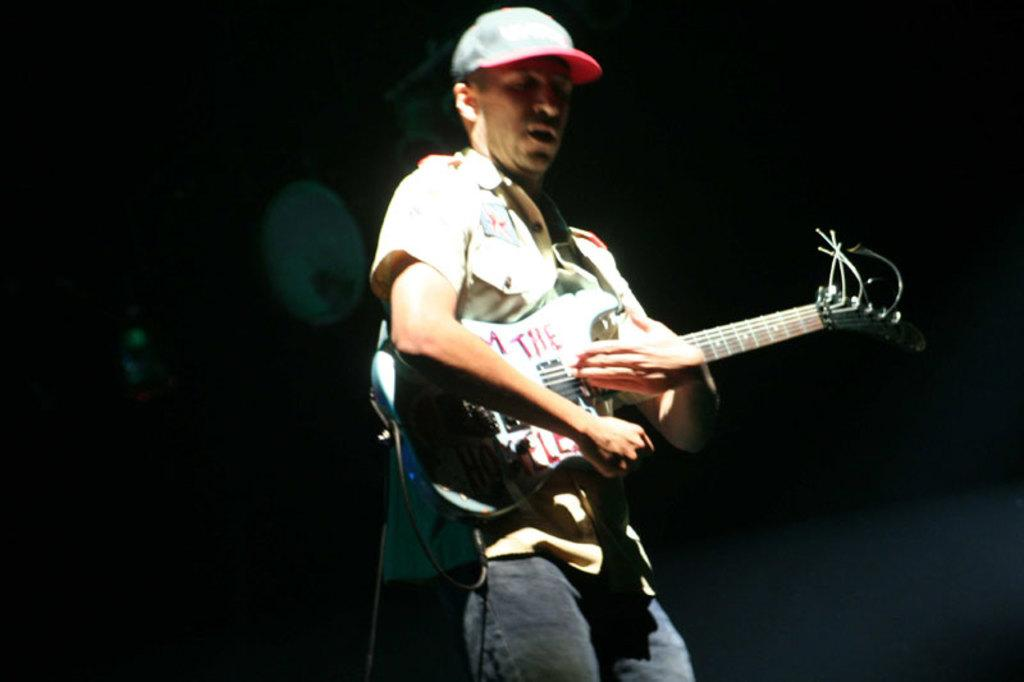What is the main subject of the image? The main subject of the image is a person. What is the person doing in the image? The person is playing a musical instrument. Can you describe the background of the image? The background of the image is dark. What type of rat can be seen attending the church service in the image? There is no rat or church service present in the image; it features a person playing a musical instrument with a dark background. 